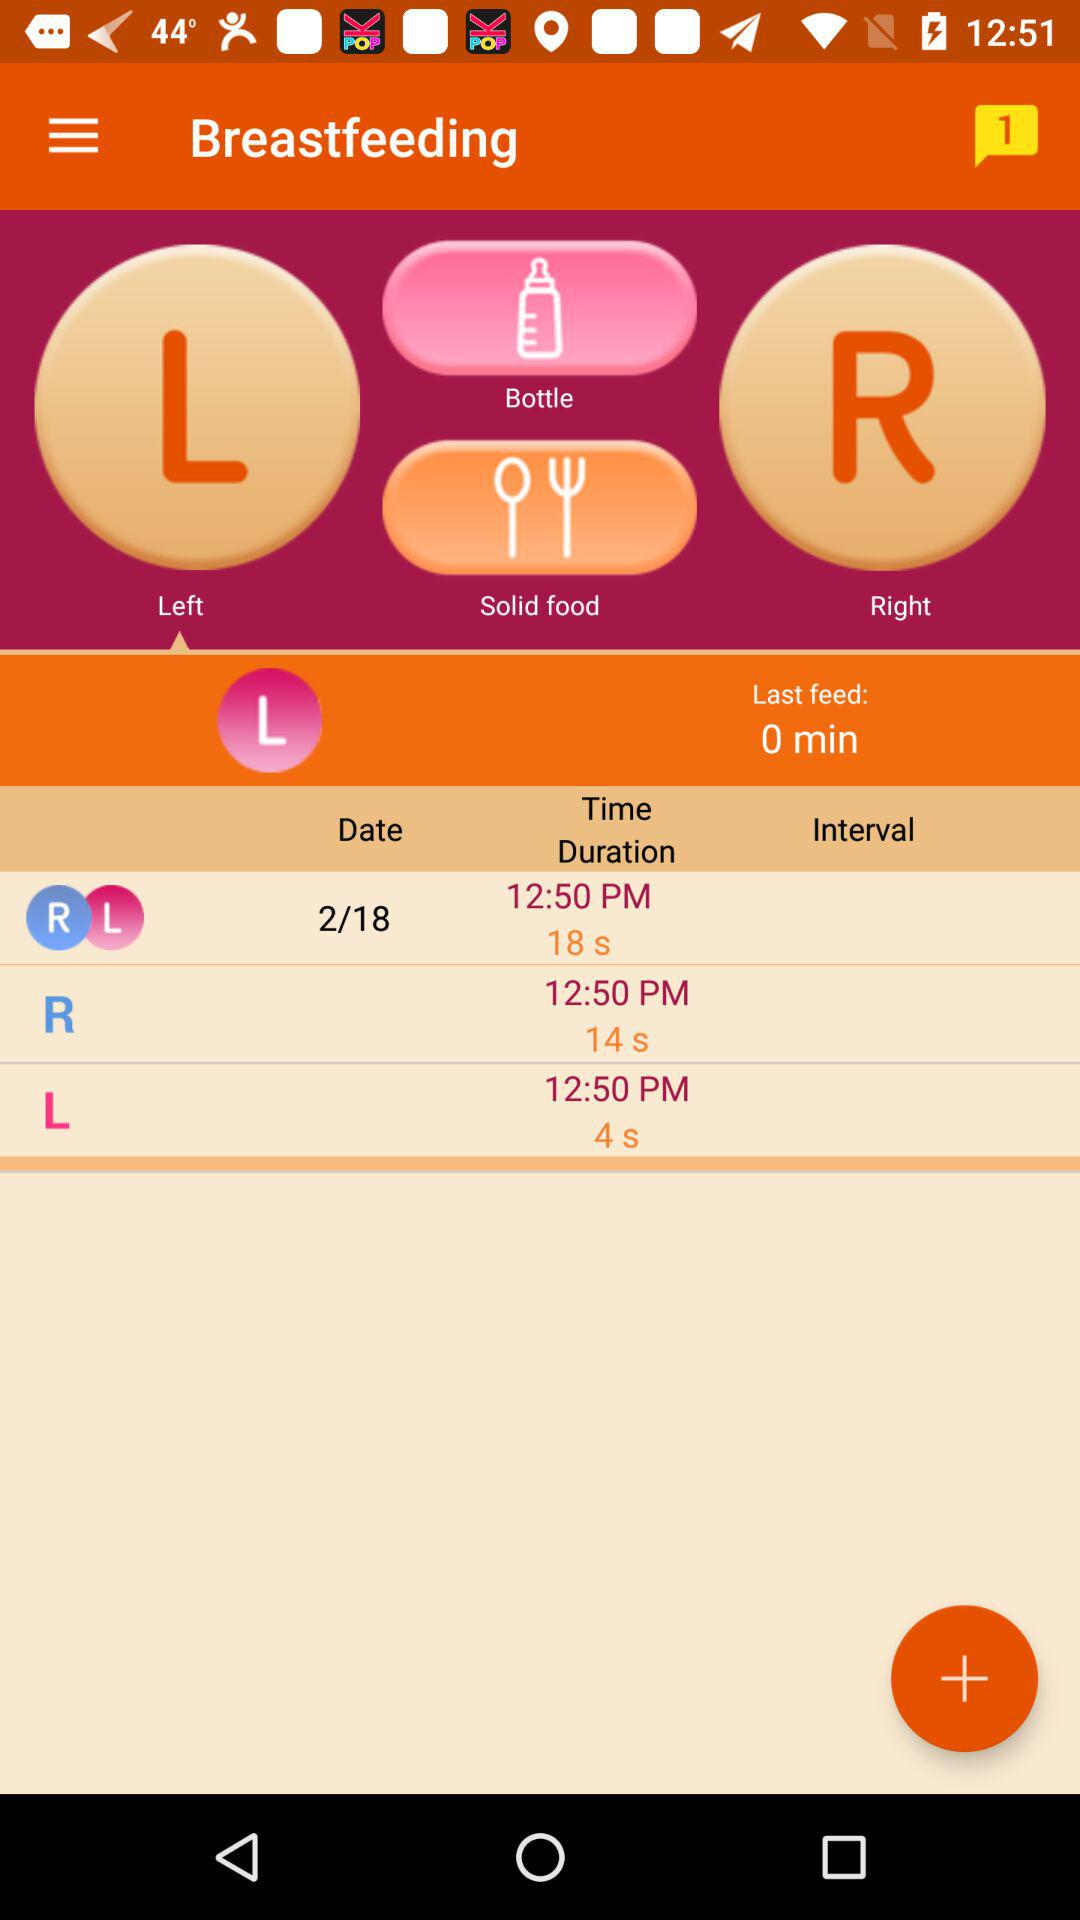What is the time given? The time is 12:50 PM. 